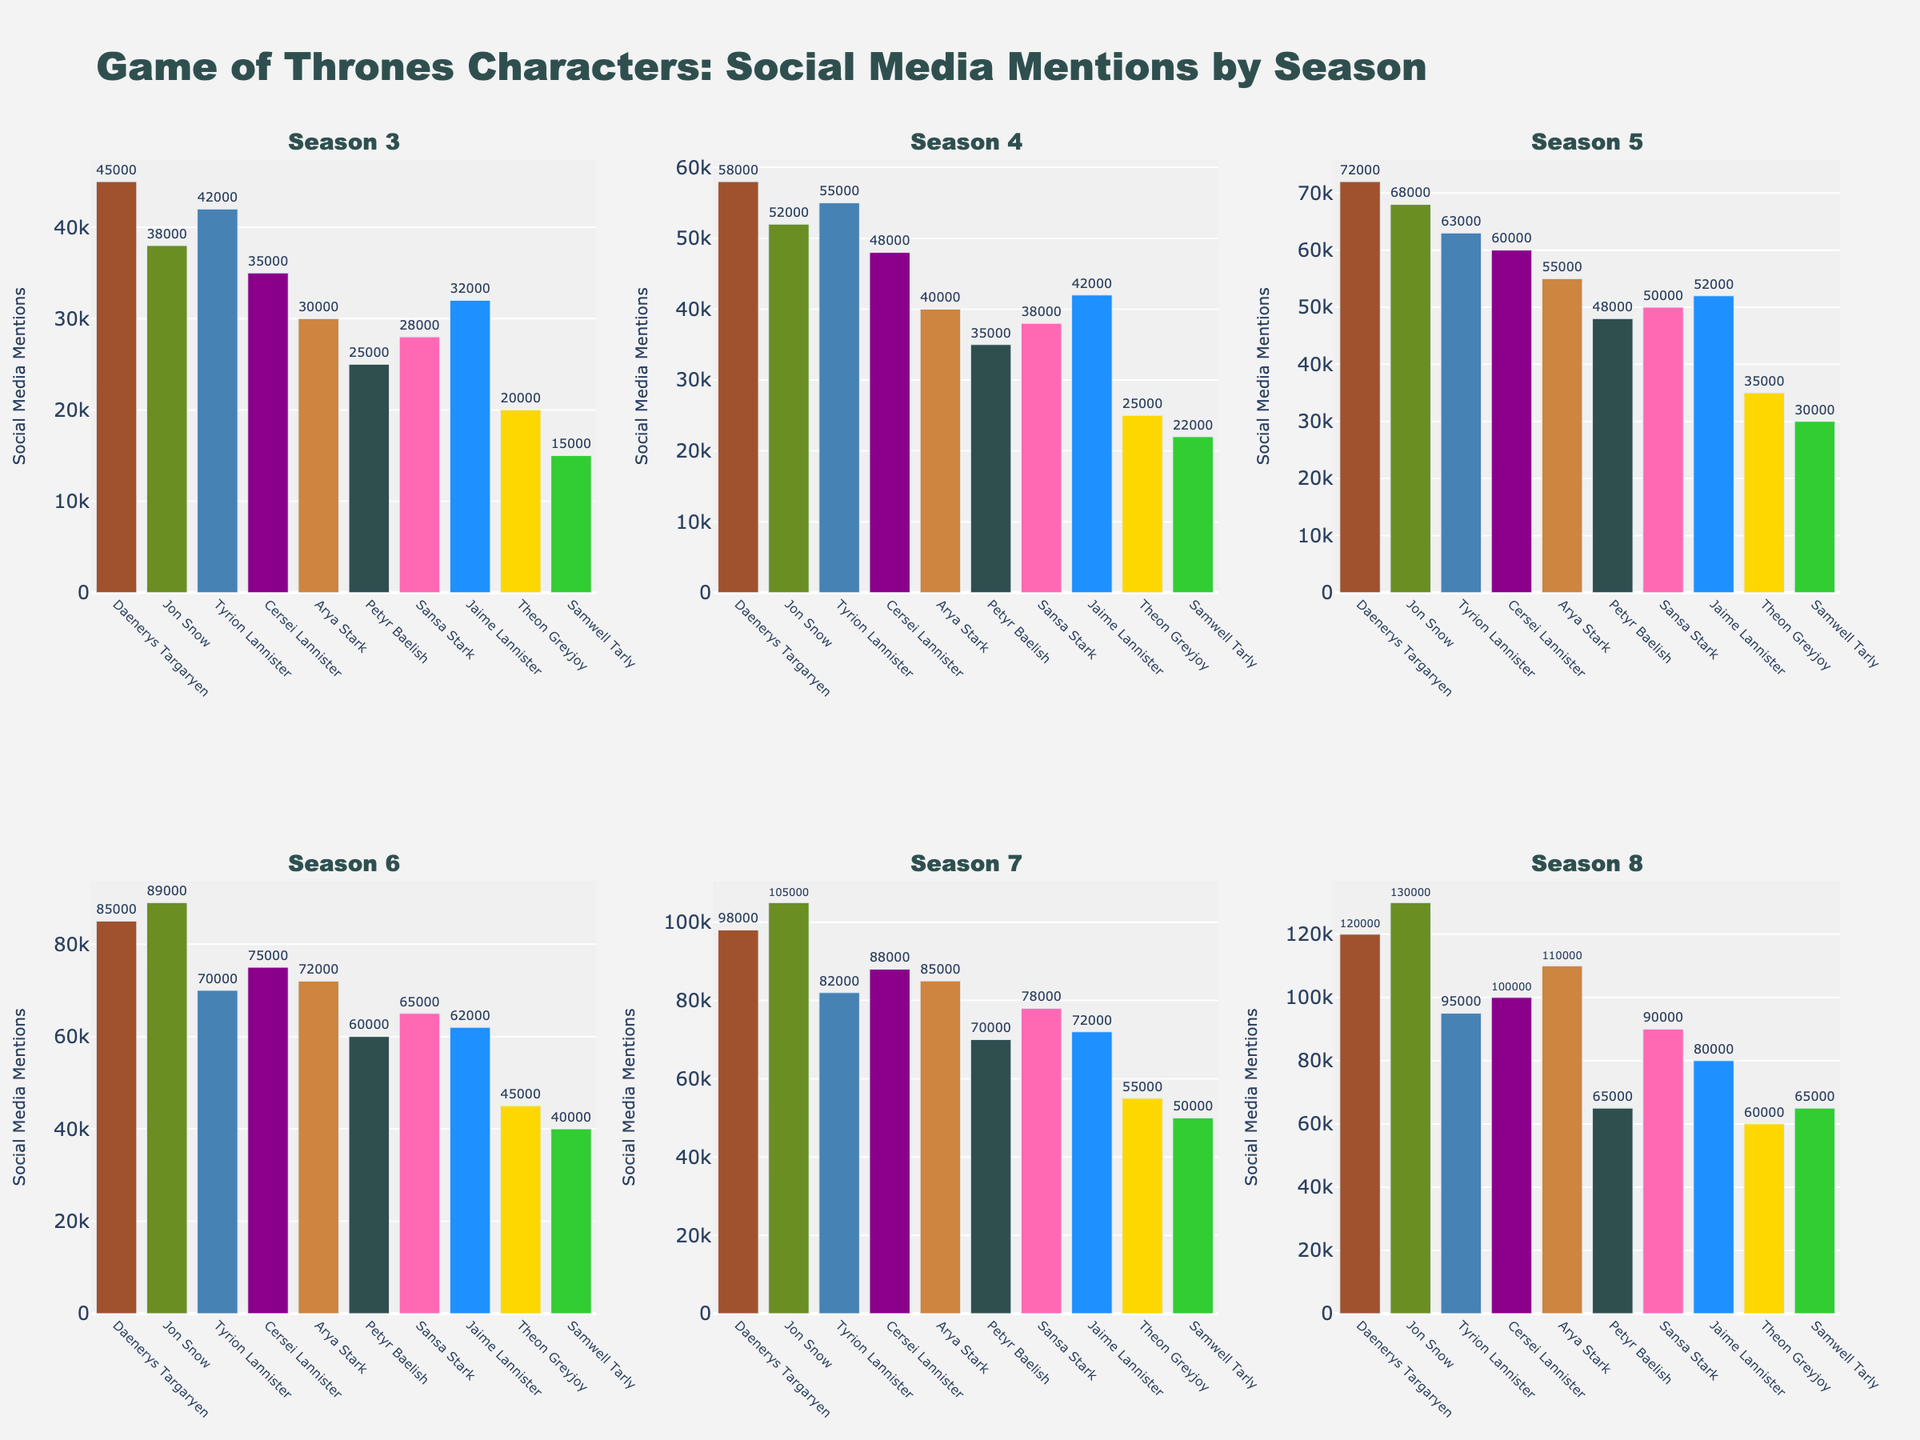Which character has the highest number of social media mentions in Season 8? The figure shows different bars for each character and season. By comparing the heights of the bars in Season 8 across all characters, Jon Snow's bar is the highest.
Answer: Jon Snow How do the social media mentions for Daenerys Targaryen change between Season 4 and Season 5? Look at the bars for Daenerys Targaryen in Season 4 and Season 5. Daenerys's mentions increase from 58,000 in Season 4 to 72,000 in Season 5.
Answer: Increase by 14,000 Who has more social media mentions in Season 6, Arya Stark or Cersei Lannister? Compare the heights of the bars for Arya Stark and Cersei Lannister in Season 6. Arya Stark has 72,000 mentions while Cersei Lannister has 75,000, so Cersei Lannister has more.
Answer: Cersei Lannister What is the total number of social media mentions for Petyr Baelish across all seasons? Sum the social media mentions for Petyr Baelish from Season 3 to Season 8: 25,000 + 35,000 + 48,000 + 60,000 + 70,000 + 65,000 = 303,000.
Answer: 303,000 In which season does Samwell Tarly see the greatest increase in social media mentions compared to the previous season? Calculate the differences in social media mentions for Samwell Tarly between consecutive seasons, and identify the largest increase: 
Season 4 - Season 3: (22,000 - 15,000) = 7,000
Season 5 - Season 4: (30,000 - 22,000) = 8,000
Season 6 - Season 5: (40,000 - 30,000) = 10,000
Season 7 - Season 6: (50,000 - 40,000) = 10,000
Season 8 - Season 7: (65,000 - 50,000) = 15,000 
Samwell Tarly's greatest increase is between Season 7 and Season 8.
Answer: Season 8 Which character has the smallest overall increase in social media mentions from Season 3 to Season 8? Calculate the difference in social media mentions for each character from Season 3 to Season 8, and identify the smallest increase:
Daenerys Targaryen: 120,000 - 45,000 = 75,000
Jon Snow: 130,000 - 38,000 = 92,000
Tyrion Lannister: 95,000 - 42,000 = 53,000
Cersei Lannister: 100,000 - 35,000 = 65,000
Arya Stark: 110,000 - 30,000 = 80,000
Petyr Baelish: 65,000 - 25,000 = 40,000
Sansa Stark: 90,000 - 28,000 = 62,000
Jaime Lannister: 80,000 - 32,000 = 48,000
Theon Greyjoy: 60,000 - 20,000 = 40,000
Samwell Tarly: 65,000 - 15,000 = 50,000 
Petyr Baelish and Theon Greyjoy both have the smallest overall increase of 40,000.
Answer: Petyr Baelish and Theon Greyjoy Between Season 5 and Season 6, which character experienced the largest absolute increase in social media mentions? Compare the absolute increases in social media mentions between Season 5 and Season 6 for each character:
Daenerys Targaryen: 85,000 - 72,000 = 13,000
Jon Snow: 89,000 - 68,000 = 21,000
Tyrion Lannister: 70,000 - 63,000 = 7,000
Cersei Lannister: 75,000 - 60,000 = 15,000
Arya Stark: 72,000 - 55,000 = 17,000
Petyr Baelish: 60,000 - 48,000 = 12,000
Sansa Stark: 65,000 - 50,000 = 15,000
Jaime Lannister: 62,000 - 52,000 = 10,000
Theon Greyjoy: 45,000 - 35,000 = 10,000
Samwell Tarly: 40,000 - 30,000 = 10,000 
Jon Snow experienced the largest absolute increase of 21,000.
Answer: Jon Snow 